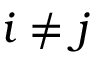<formula> <loc_0><loc_0><loc_500><loc_500>i \neq j</formula> 